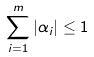Convert formula to latex. <formula><loc_0><loc_0><loc_500><loc_500>\sum _ { i = 1 } ^ { m } | \alpha _ { i } | \leq 1</formula> 